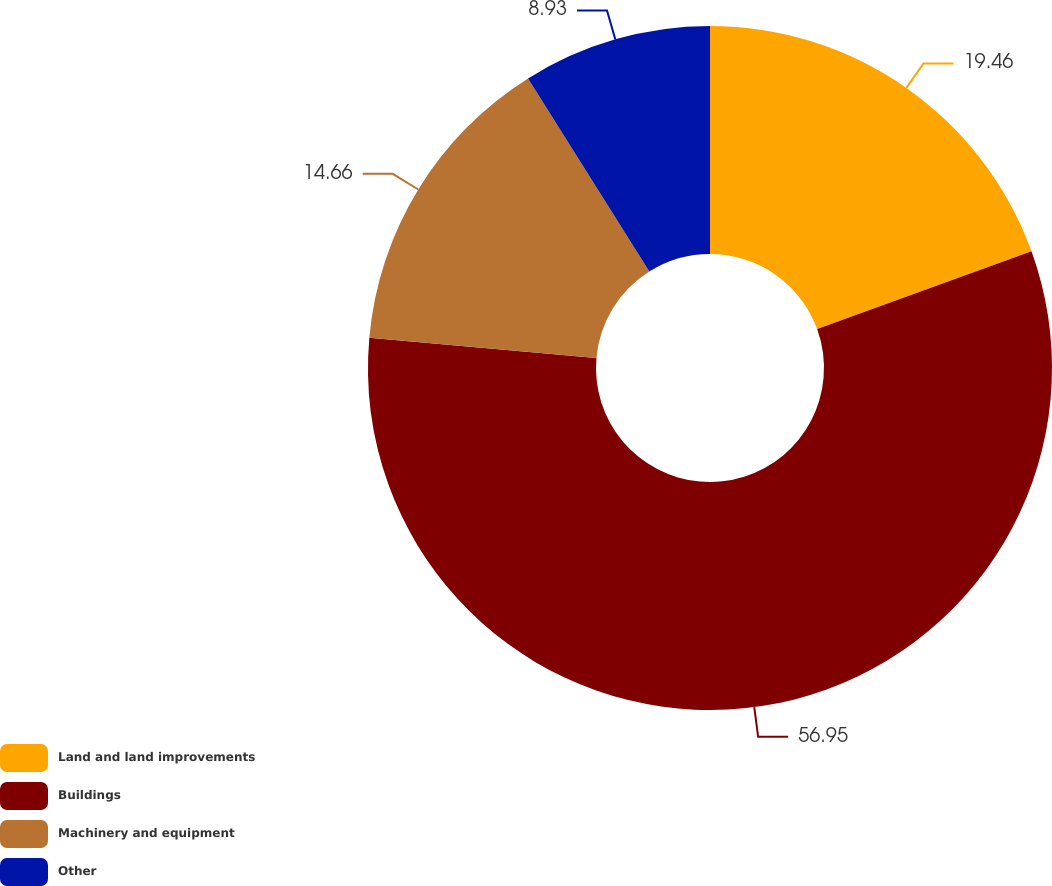<chart> <loc_0><loc_0><loc_500><loc_500><pie_chart><fcel>Land and land improvements<fcel>Buildings<fcel>Machinery and equipment<fcel>Other<nl><fcel>19.46%<fcel>56.95%<fcel>14.66%<fcel>8.93%<nl></chart> 